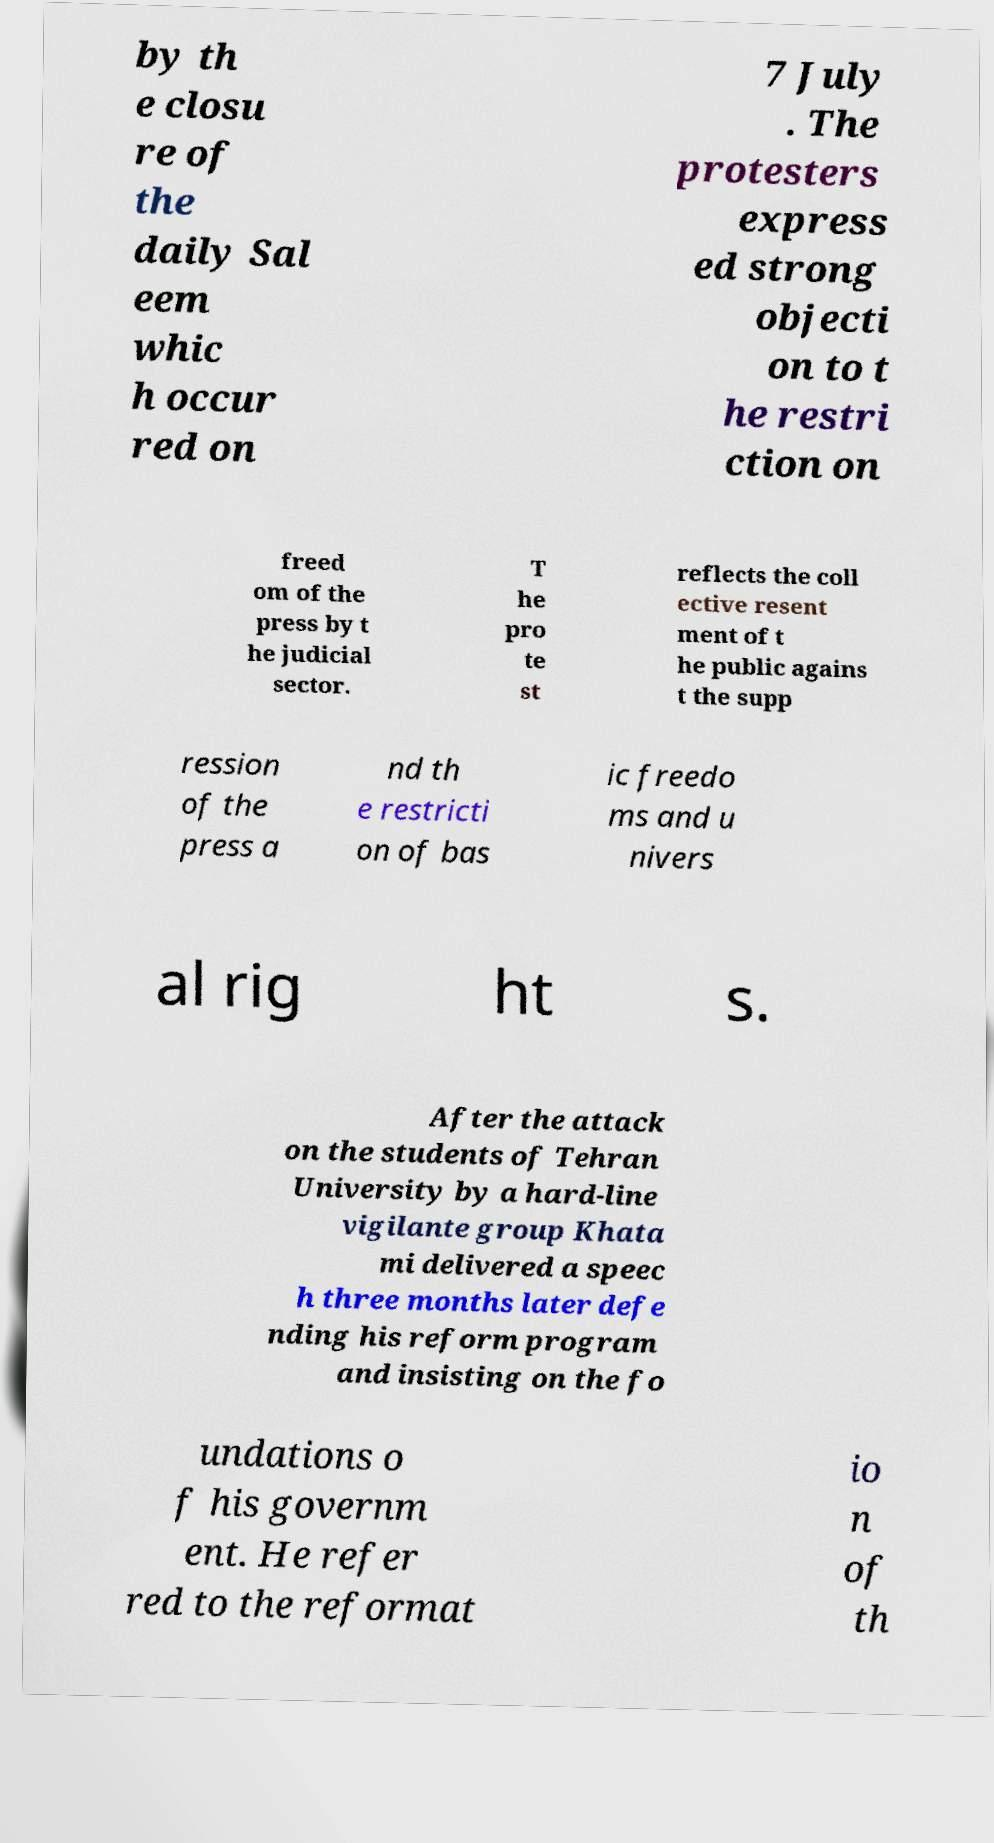I need the written content from this picture converted into text. Can you do that? by th e closu re of the daily Sal eem whic h occur red on 7 July . The protesters express ed strong objecti on to t he restri ction on freed om of the press by t he judicial sector. T he pro te st reflects the coll ective resent ment of t he public agains t the supp ression of the press a nd th e restricti on of bas ic freedo ms and u nivers al rig ht s. After the attack on the students of Tehran University by a hard-line vigilante group Khata mi delivered a speec h three months later defe nding his reform program and insisting on the fo undations o f his governm ent. He refer red to the reformat io n of th 